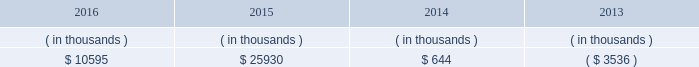Entergy mississippi , inc .
Management 2019s financial discussion and analysis entergy mississippi 2019s receivables from or ( payables to ) the money pool were as follows as of december 31 for each of the following years. .
See note 4 to the financial statements for a description of the money pool .
Entergy mississippi has four separate credit facilities in the aggregate amount of $ 102.5 million scheduled to expire may 2017 .
No borrowings were outstanding under the credit facilities as of december 31 , 2016 .
In addition , entergy mississippi is a party to an uncommitted letter of credit facility as a means to post collateral to support its obligations under miso .
As of december 31 , 2016 , a $ 7.1 million letter of credit was outstanding under entergy mississippi 2019s uncommitted letter of credit facility .
See note 4 to the financial statements for additional discussion of the credit facilities .
Entergy mississippi obtained authorizations from the ferc through october 2017 for short-term borrowings not to exceed an aggregate amount of $ 175 million at any time outstanding and long-term borrowings and security issuances .
See note 4 to the financial statements for further discussion of entergy mississippi 2019s short-term borrowing limits .
State and local rate regulation and fuel-cost recovery the rates that entergy mississippi charges for electricity significantly influence its financial position , results of operations , and liquidity .
Entergy mississippi is regulated and the rates charged to its customers are determined in regulatory proceedings .
A governmental agency , the mpsc , is primarily responsible for approval of the rates charged to customers .
Formula rate plan in june 2014 , entergy mississippi filed its first general rate case before the mpsc in almost 12 years .
The rate filing laid out entergy mississippi 2019s plans for improving reliability , modernizing the grid , maintaining its workforce , stabilizing rates , utilizing new technologies , and attracting new industry to its service territory .
Entergy mississippi requested a net increase in revenue of $ 49 million for bills rendered during calendar year 2015 , including $ 30 million resulting from new depreciation rates to update the estimated service life of assets .
In addition , the filing proposed , among other things : 1 ) realigning cost recovery of the attala and hinds power plant acquisitions from the power management rider to base rates ; 2 ) including certain miso-related revenues and expenses in the power management rider ; 3 ) power management rider changes that reflect the changes in costs and revenues that will accompany entergy mississippi 2019s withdrawal from participation in the system agreement ; and 4 ) a formula rate plan forward test year to allow for known changes in expenses and revenues for the rate effective period .
Entergy mississippi proposed maintaining the current authorized return on common equity of 10.59% ( 10.59 % ) .
In october 2014 , entergy mississippi and the mississippi public utilities staff entered into and filed joint stipulations that addressed the majority of issues in the proceeding .
The stipulations provided for : 2022 an approximate $ 16 million net increase in revenues , which reflected an agreed upon 10.07% ( 10.07 % ) return on common equity ; 2022 revision of entergy mississippi 2019s formula rate plan by providing entergy mississippi with the ability to reflect known and measurable changes to historical rate base and certain expense amounts ; resolving uncertainty around and obviating the need for an additional rate filing in connection with entergy mississippi 2019s withdrawal from participation in the system agreement ; updating depreciation rates ; and moving costs associated with the attala and hinds generating plants from the power management rider to base rates; .
The company has four separate credit facilities expiring in may 2017 . what was the average amount in millions of those four facilties? 
Computations: (102.5 / 4)
Answer: 25.625. 